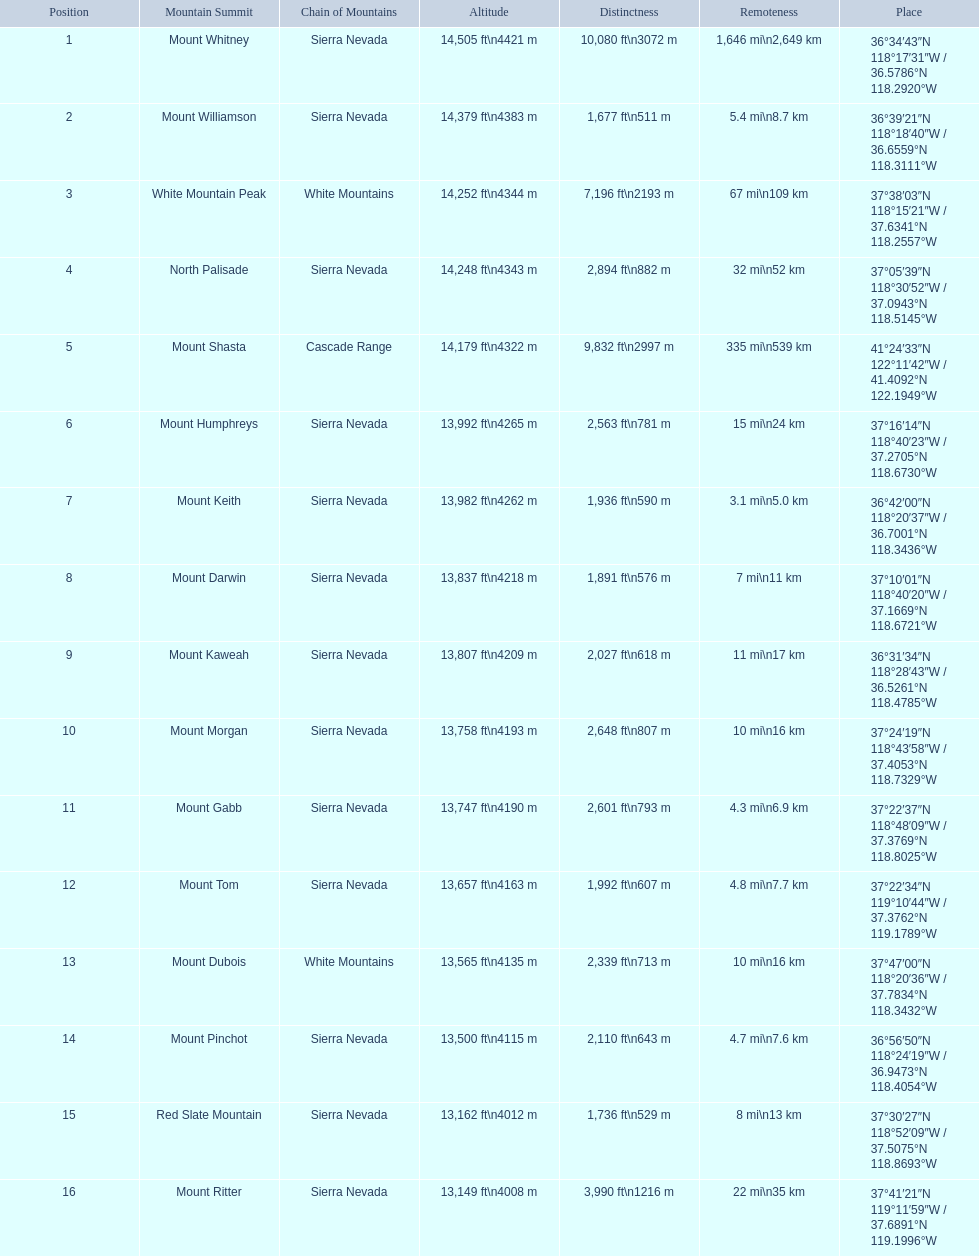Which are the mountain peaks? Mount Whitney, Mount Williamson, White Mountain Peak, North Palisade, Mount Shasta, Mount Humphreys, Mount Keith, Mount Darwin, Mount Kaweah, Mount Morgan, Mount Gabb, Mount Tom, Mount Dubois, Mount Pinchot, Red Slate Mountain, Mount Ritter. Of these, which is in the cascade range? Mount Shasta. 